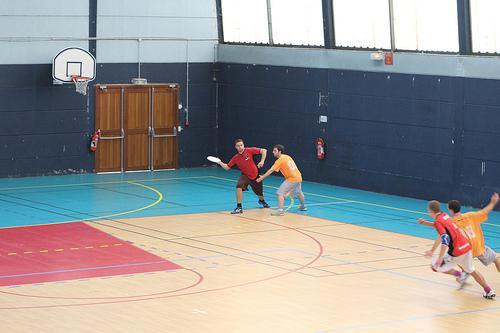Question: where are they?
Choices:
A. In the park.
B. On the street corner.
C. In the playing court.
D. At the zoo.
Answer with the letter. Answer: C Question: how many players are there?
Choices:
A. Five.
B. Six.
C. Seven.
D. Four.
Answer with the letter. Answer: D Question: what are they playing?
Choices:
A. Cards.
B. Hopscotch.
C. A game.
D. A video game.
Answer with the letter. Answer: C Question: what is shining through the window?
Choices:
A. Light.
B. Moon.
C. Sun.
D. Reflection.
Answer with the letter. Answer: A Question: who is throwing the frisbee?
Choices:
A. A boy.
B. A girl.
C. Man in red.
D. A woman in a clown costume.
Answer with the letter. Answer: C 